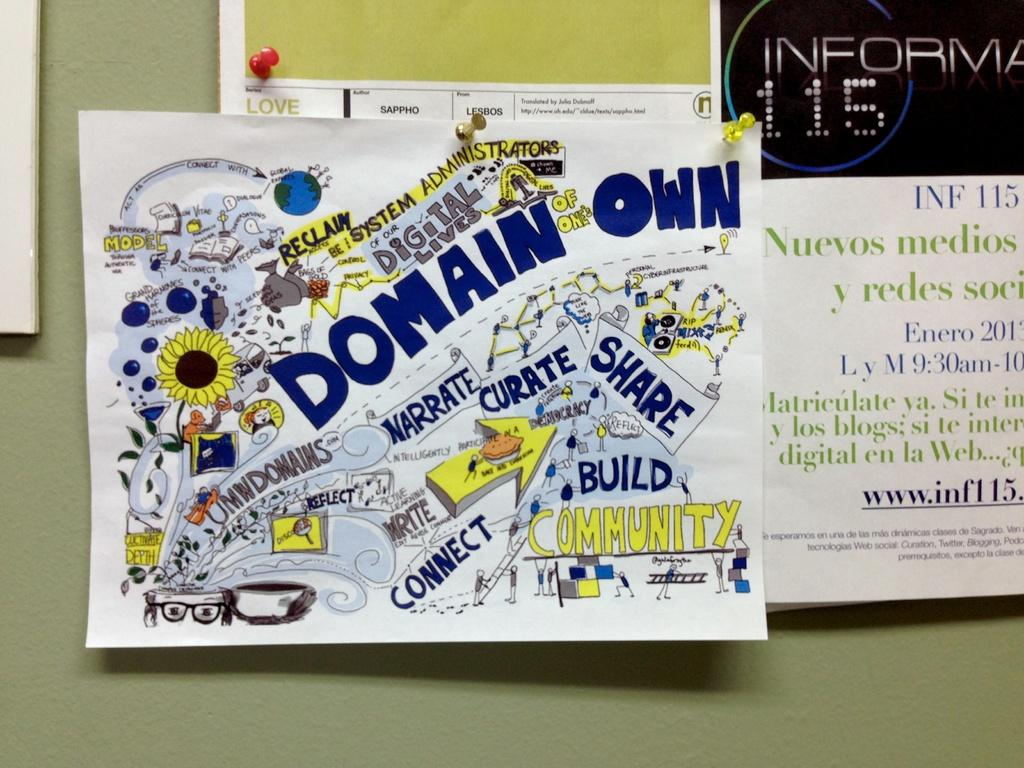<image>
Give a short and clear explanation of the subsequent image. Poster hung on a wall that says Domain Own in blue. 